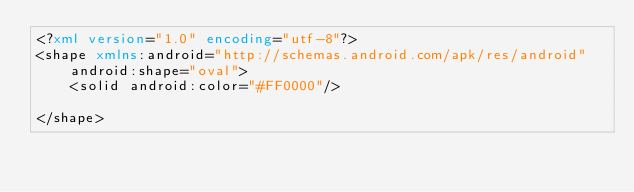<code> <loc_0><loc_0><loc_500><loc_500><_XML_><?xml version="1.0" encoding="utf-8"?>
<shape xmlns:android="http://schemas.android.com/apk/res/android"
    android:shape="oval">
    <solid android:color="#FF0000"/>

</shape></code> 